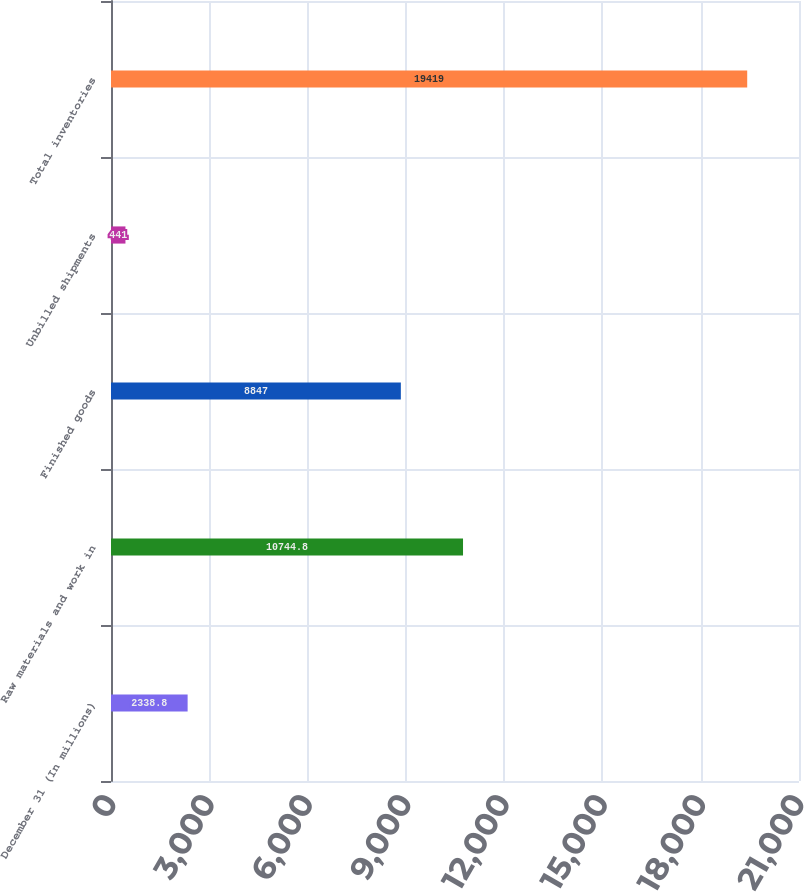Convert chart to OTSL. <chart><loc_0><loc_0><loc_500><loc_500><bar_chart><fcel>December 31 (In millions)<fcel>Raw materials and work in<fcel>Finished goods<fcel>Unbilled shipments<fcel>Total inventories<nl><fcel>2338.8<fcel>10744.8<fcel>8847<fcel>441<fcel>19419<nl></chart> 